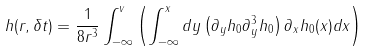Convert formula to latex. <formula><loc_0><loc_0><loc_500><loc_500>h ( r , \delta t ) = \frac { 1 } { 8 r ^ { 3 } } \int _ { - \infty } ^ { v } \left ( \int _ { - \infty } ^ { x } d y \left ( \partial _ { y } h _ { 0 } \partial _ { y } ^ { 3 } h _ { 0 } \right ) \partial _ { x } h _ { 0 } ( x ) d x \right )</formula> 